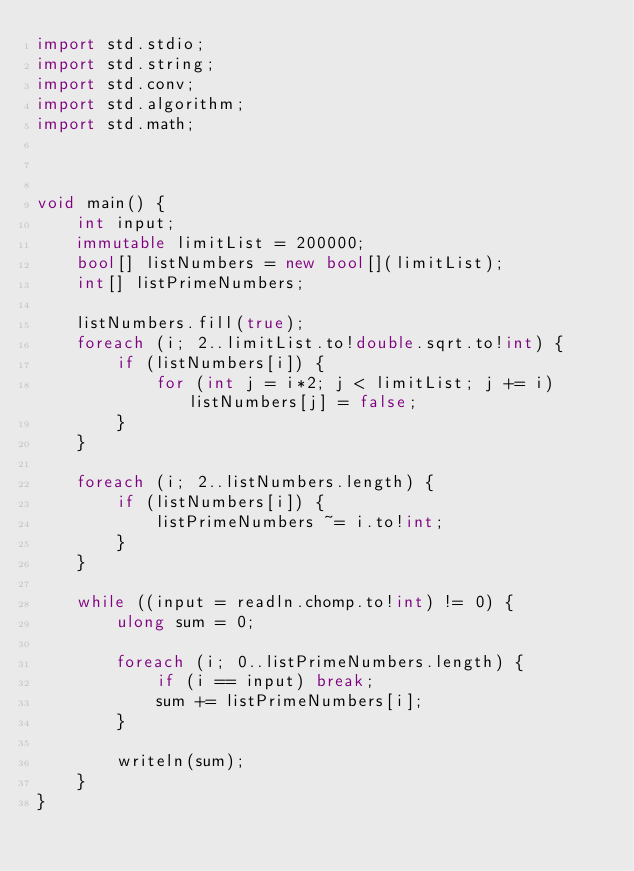<code> <loc_0><loc_0><loc_500><loc_500><_D_>import std.stdio;
import std.string;
import std.conv;
import std.algorithm;
import std.math;



void main() {
    int input;
    immutable limitList = 200000;
    bool[] listNumbers = new bool[](limitList);
    int[] listPrimeNumbers;

    listNumbers.fill(true);
    foreach (i; 2..limitList.to!double.sqrt.to!int) {
        if (listNumbers[i]) {
            for (int j = i*2; j < limitList; j += i) listNumbers[j] = false;
        }
    }

    foreach (i; 2..listNumbers.length) {
        if (listNumbers[i]) {
            listPrimeNumbers ~= i.to!int;
        }
    }

    while ((input = readln.chomp.to!int) != 0) {
        ulong sum = 0;

        foreach (i; 0..listPrimeNumbers.length) {
            if (i == input) break;
            sum += listPrimeNumbers[i];
        }

        writeln(sum);
    }
}</code> 